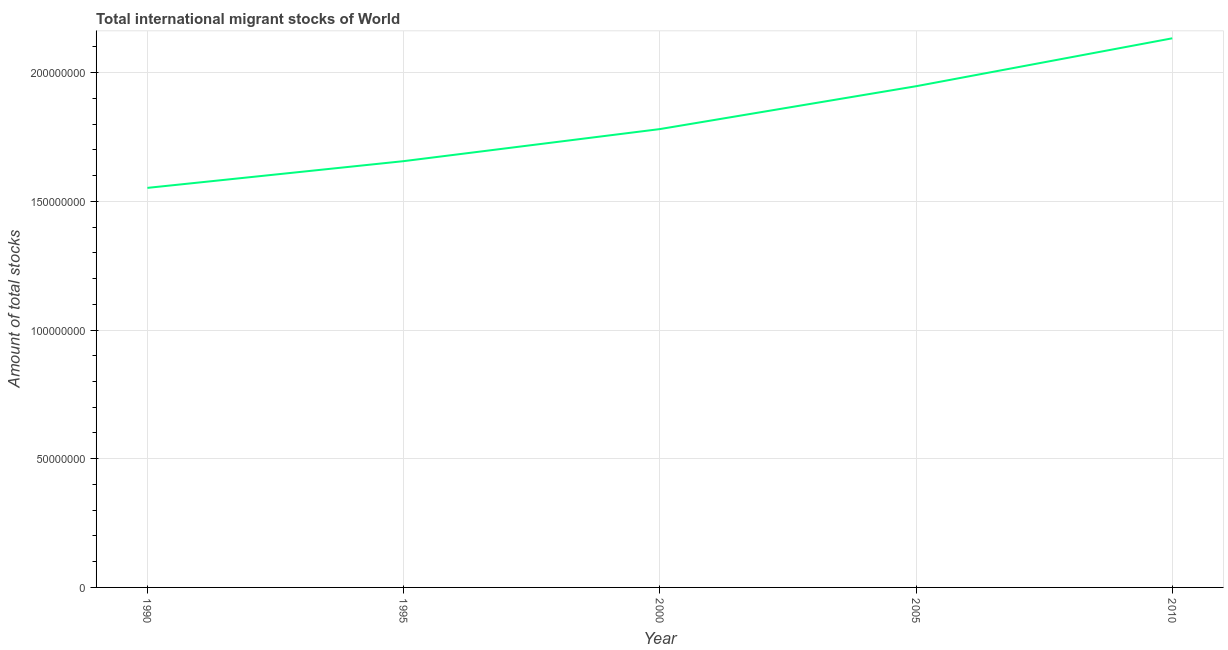What is the total number of international migrant stock in 2000?
Provide a succinct answer. 1.78e+08. Across all years, what is the maximum total number of international migrant stock?
Make the answer very short. 2.13e+08. Across all years, what is the minimum total number of international migrant stock?
Provide a succinct answer. 1.55e+08. In which year was the total number of international migrant stock maximum?
Your answer should be compact. 2010. In which year was the total number of international migrant stock minimum?
Ensure brevity in your answer.  1990. What is the sum of the total number of international migrant stock?
Your answer should be compact. 9.07e+08. What is the difference between the total number of international migrant stock in 2005 and 2010?
Offer a very short reply. -1.86e+07. What is the average total number of international migrant stock per year?
Offer a very short reply. 1.81e+08. What is the median total number of international migrant stock?
Make the answer very short. 1.78e+08. In how many years, is the total number of international migrant stock greater than 100000000 ?
Your response must be concise. 5. What is the ratio of the total number of international migrant stock in 1990 to that in 2000?
Your response must be concise. 0.87. Is the total number of international migrant stock in 1990 less than that in 2010?
Offer a terse response. Yes. What is the difference between the highest and the second highest total number of international migrant stock?
Give a very brief answer. 1.86e+07. What is the difference between the highest and the lowest total number of international migrant stock?
Your response must be concise. 5.81e+07. How many lines are there?
Offer a very short reply. 1. How many years are there in the graph?
Give a very brief answer. 5. What is the difference between two consecutive major ticks on the Y-axis?
Offer a terse response. 5.00e+07. Are the values on the major ticks of Y-axis written in scientific E-notation?
Your response must be concise. No. What is the title of the graph?
Make the answer very short. Total international migrant stocks of World. What is the label or title of the X-axis?
Keep it short and to the point. Year. What is the label or title of the Y-axis?
Offer a very short reply. Amount of total stocks. What is the Amount of total stocks of 1990?
Make the answer very short. 1.55e+08. What is the Amount of total stocks of 1995?
Your response must be concise. 1.66e+08. What is the Amount of total stocks in 2000?
Ensure brevity in your answer.  1.78e+08. What is the Amount of total stocks in 2005?
Your response must be concise. 1.95e+08. What is the Amount of total stocks in 2010?
Your response must be concise. 2.13e+08. What is the difference between the Amount of total stocks in 1990 and 1995?
Your response must be concise. -1.04e+07. What is the difference between the Amount of total stocks in 1990 and 2000?
Offer a very short reply. -2.28e+07. What is the difference between the Amount of total stocks in 1990 and 2005?
Ensure brevity in your answer.  -3.95e+07. What is the difference between the Amount of total stocks in 1990 and 2010?
Offer a terse response. -5.81e+07. What is the difference between the Amount of total stocks in 1995 and 2000?
Your answer should be very brief. -1.25e+07. What is the difference between the Amount of total stocks in 1995 and 2005?
Your answer should be very brief. -2.91e+07. What is the difference between the Amount of total stocks in 1995 and 2010?
Make the answer very short. -4.77e+07. What is the difference between the Amount of total stocks in 2000 and 2005?
Your response must be concise. -1.66e+07. What is the difference between the Amount of total stocks in 2000 and 2010?
Ensure brevity in your answer.  -3.53e+07. What is the difference between the Amount of total stocks in 2005 and 2010?
Keep it short and to the point. -1.86e+07. What is the ratio of the Amount of total stocks in 1990 to that in 1995?
Make the answer very short. 0.94. What is the ratio of the Amount of total stocks in 1990 to that in 2000?
Your answer should be compact. 0.87. What is the ratio of the Amount of total stocks in 1990 to that in 2005?
Your response must be concise. 0.8. What is the ratio of the Amount of total stocks in 1990 to that in 2010?
Your answer should be very brief. 0.73. What is the ratio of the Amount of total stocks in 1995 to that in 2005?
Provide a short and direct response. 0.85. What is the ratio of the Amount of total stocks in 1995 to that in 2010?
Make the answer very short. 0.78. What is the ratio of the Amount of total stocks in 2000 to that in 2005?
Your response must be concise. 0.91. What is the ratio of the Amount of total stocks in 2000 to that in 2010?
Keep it short and to the point. 0.83. 